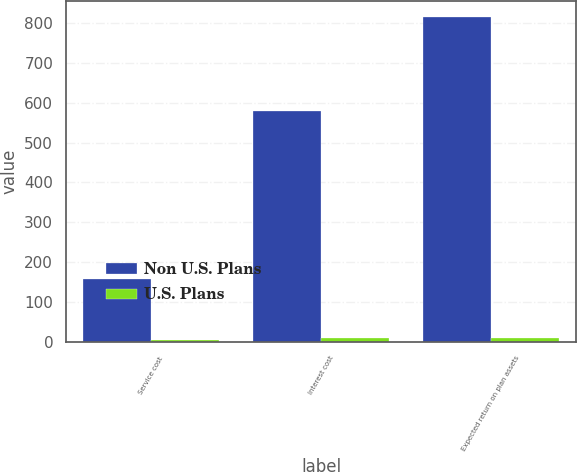Convert chart to OTSL. <chart><loc_0><loc_0><loc_500><loc_500><stacked_bar_chart><ecel><fcel>Service cost<fcel>Interest cost<fcel>Expected return on plan assets<nl><fcel>Non U.S. Plans<fcel>158<fcel>580<fcel>815<nl><fcel>U.S. Plans<fcel>4<fcel>9<fcel>10<nl></chart> 